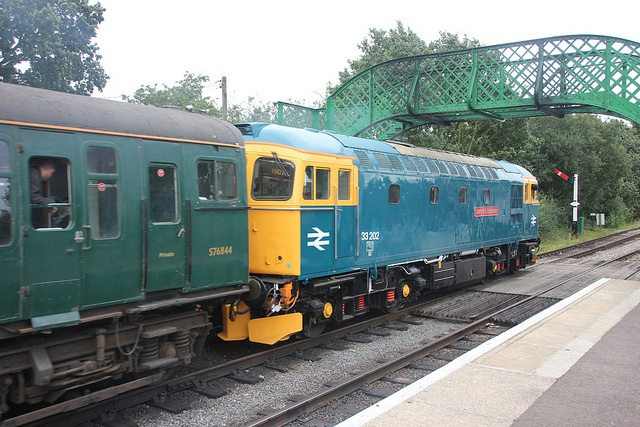Describe the objects in this image and their specific colors. I can see train in darkgray, black, teal, and gray tones and people in darkgray, gray, and black tones in this image. 